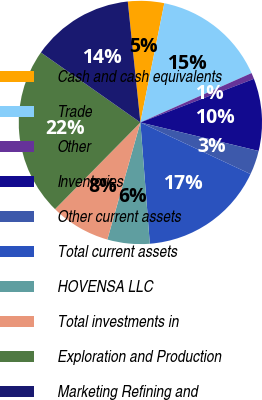Convert chart. <chart><loc_0><loc_0><loc_500><loc_500><pie_chart><fcel>Cash and cash equivalents<fcel>Trade<fcel>Other<fcel>Inventories<fcel>Other current assets<fcel>Total current assets<fcel>HOVENSA LLC<fcel>Total investments in<fcel>Exploration and Production<fcel>Marketing Refining and<nl><fcel>4.81%<fcel>15.19%<fcel>0.82%<fcel>9.6%<fcel>3.21%<fcel>16.79%<fcel>5.61%<fcel>8.0%<fcel>22.38%<fcel>13.59%<nl></chart> 